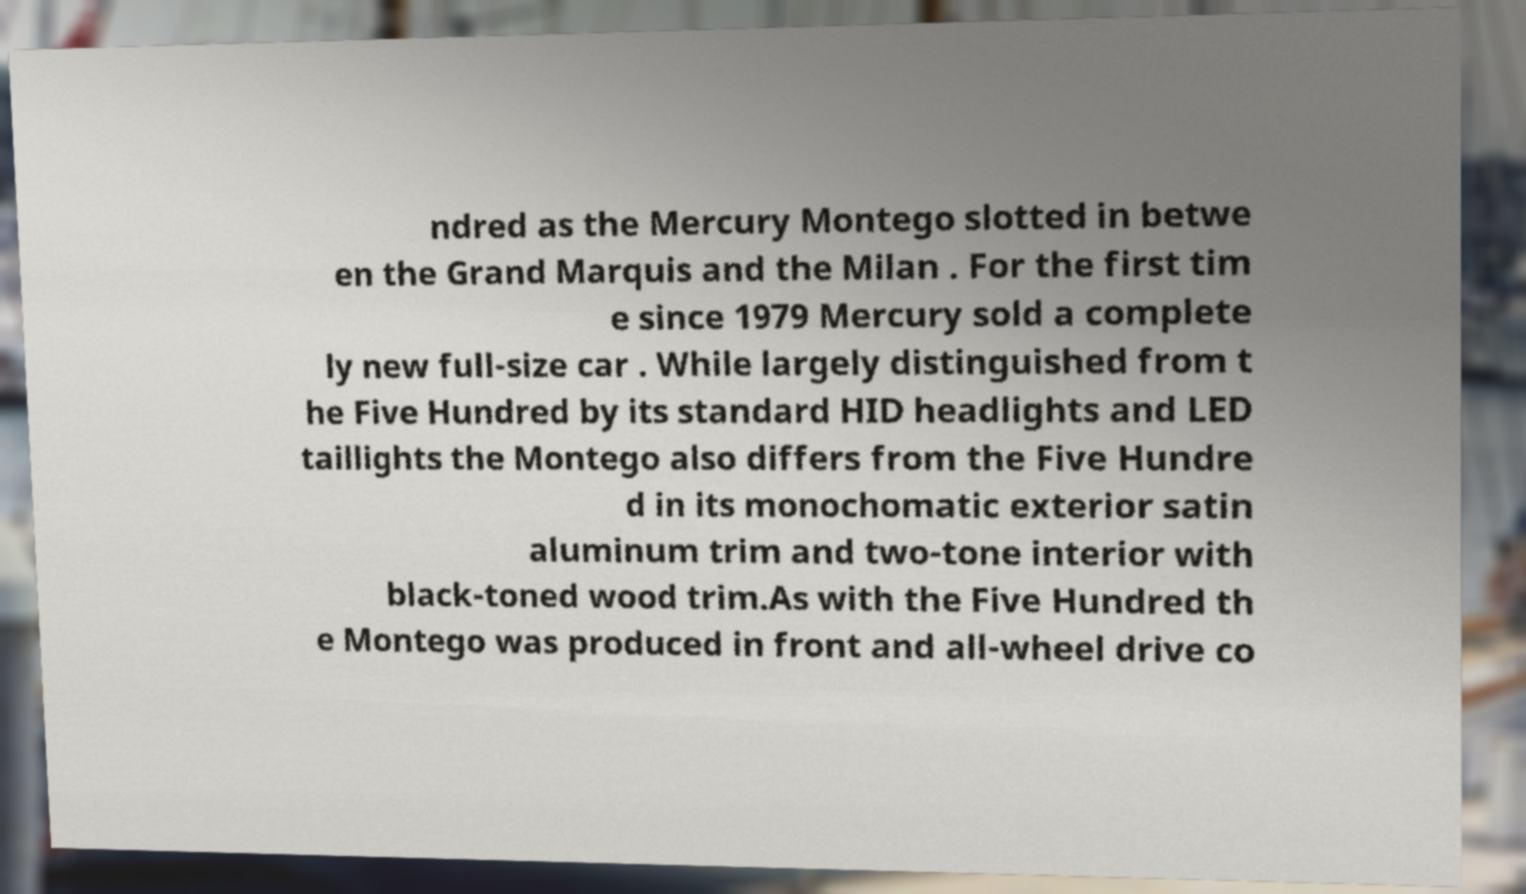What messages or text are displayed in this image? I need them in a readable, typed format. ndred as the Mercury Montego slotted in betwe en the Grand Marquis and the Milan . For the first tim e since 1979 Mercury sold a complete ly new full-size car . While largely distinguished from t he Five Hundred by its standard HID headlights and LED taillights the Montego also differs from the Five Hundre d in its monochomatic exterior satin aluminum trim and two-tone interior with black-toned wood trim.As with the Five Hundred th e Montego was produced in front and all-wheel drive co 